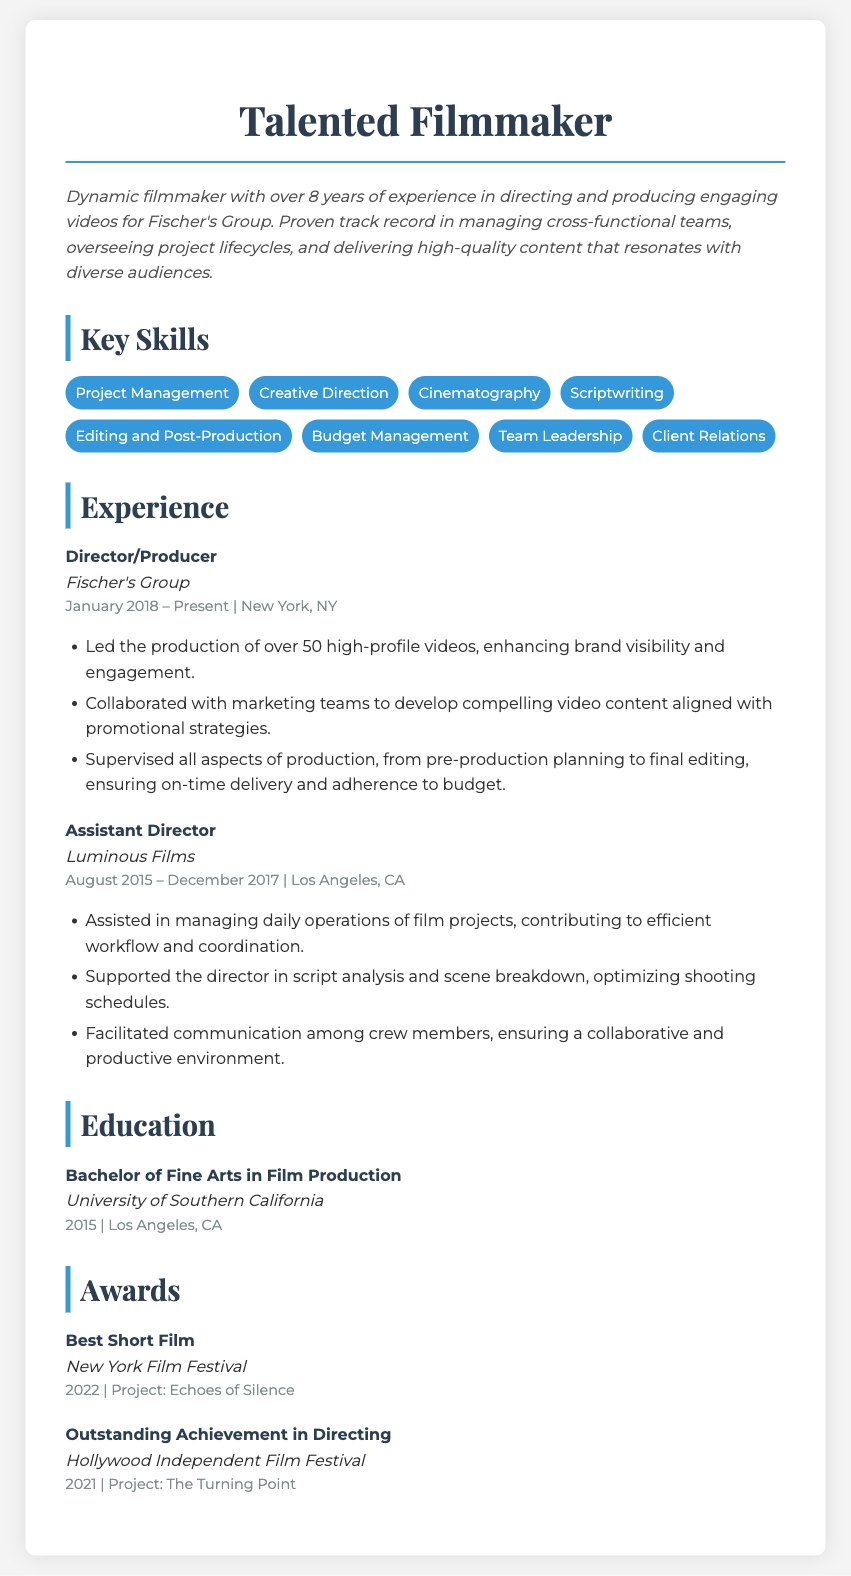What is the title of the resume? The title of the resume is prominently displayed at the top of the document.
Answer: Talented Filmmaker How many years of experience does the filmmaker have? The document mentions the total years of experience in the professional summary section.
Answer: 8 years Which company does the filmmaker currently work for? The current employer is indicated in the experience section.
Answer: Fischer's Group What degree does the filmmaker hold? The educational background specifies the degree acquired.
Answer: Bachelor of Fine Arts in Film Production What is one of the skills listed in the resume? The skills section provides a list of skills relevant to film production.
Answer: Project Management In which year did the filmmaker win the Best Short Film award? The award section specifies the year the filmmaker received this recognition.
Answer: 2022 What position did the filmmaker hold at Luminous Films? The experience section outlines the job titles held in previous positions.
Answer: Assistant Director What city is the filmmaker based in? The location of the current position is mentioned in the experience section.
Answer: New York, NY How many high-profile videos has the filmmaker led the production of? The experience section indicates the total number of videos produced.
Answer: Over 50 